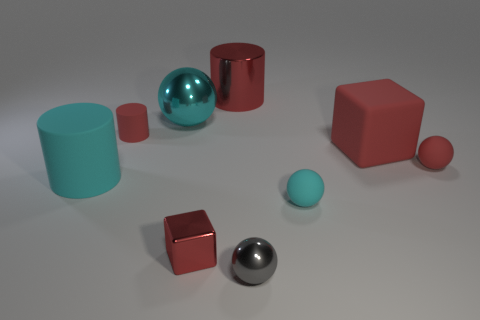What number of other objects are there of the same shape as the gray metal object?
Make the answer very short. 3. There is a red shiny object in front of the small matte sphere that is behind the big cyan cylinder; how many tiny red objects are left of it?
Ensure brevity in your answer.  1. There is a block that is left of the small gray object; what is its color?
Your answer should be very brief. Red. There is a matte object in front of the cyan cylinder; does it have the same color as the large sphere?
Your answer should be very brief. Yes. The cyan rubber object that is the same shape as the tiny gray thing is what size?
Your response must be concise. Small. The small red thing in front of the tiny red matte object that is on the right side of the shiny sphere behind the small gray ball is made of what material?
Make the answer very short. Metal. Are there more red things that are in front of the tiny gray ball than tiny red shiny things that are behind the metal cylinder?
Offer a terse response. No. Do the cyan shiny sphere and the cyan rubber cylinder have the same size?
Your answer should be compact. Yes. The large thing that is the same shape as the small cyan rubber object is what color?
Your answer should be very brief. Cyan. How many big matte things are the same color as the small matte cylinder?
Offer a terse response. 1. 